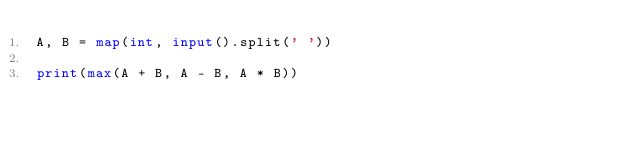<code> <loc_0><loc_0><loc_500><loc_500><_Python_>A, B = map(int, input().split(' '))

print(max(A + B, A - B, A * B))</code> 